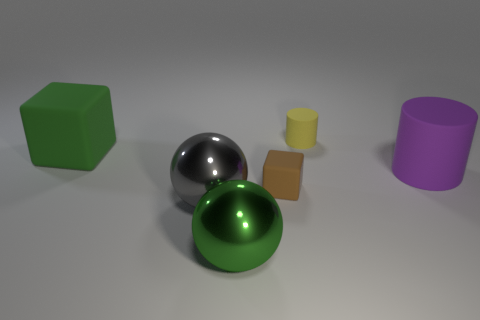There is a gray object that is in front of the large purple cylinder; what size is it?
Provide a short and direct response. Large. Are there any other small green spheres made of the same material as the green ball?
Keep it short and to the point. No. There is a rubber block that is to the right of the big green matte cube; does it have the same color as the tiny matte cylinder?
Your answer should be very brief. No. Is the number of small matte things that are in front of the purple rubber object the same as the number of brown rubber blocks?
Make the answer very short. Yes. Are there any big metallic balls of the same color as the big rubber cube?
Keep it short and to the point. Yes. Is the size of the green metal object the same as the gray shiny ball?
Your response must be concise. Yes. What is the size of the block that is on the right side of the metal sphere that is to the left of the big green sphere?
Your answer should be compact. Small. There is a object that is both to the left of the purple cylinder and to the right of the tiny brown rubber cube; what is its size?
Make the answer very short. Small. What number of other matte things are the same size as the yellow object?
Your response must be concise. 1. How many metallic things are cylinders or large yellow spheres?
Offer a very short reply. 0. 